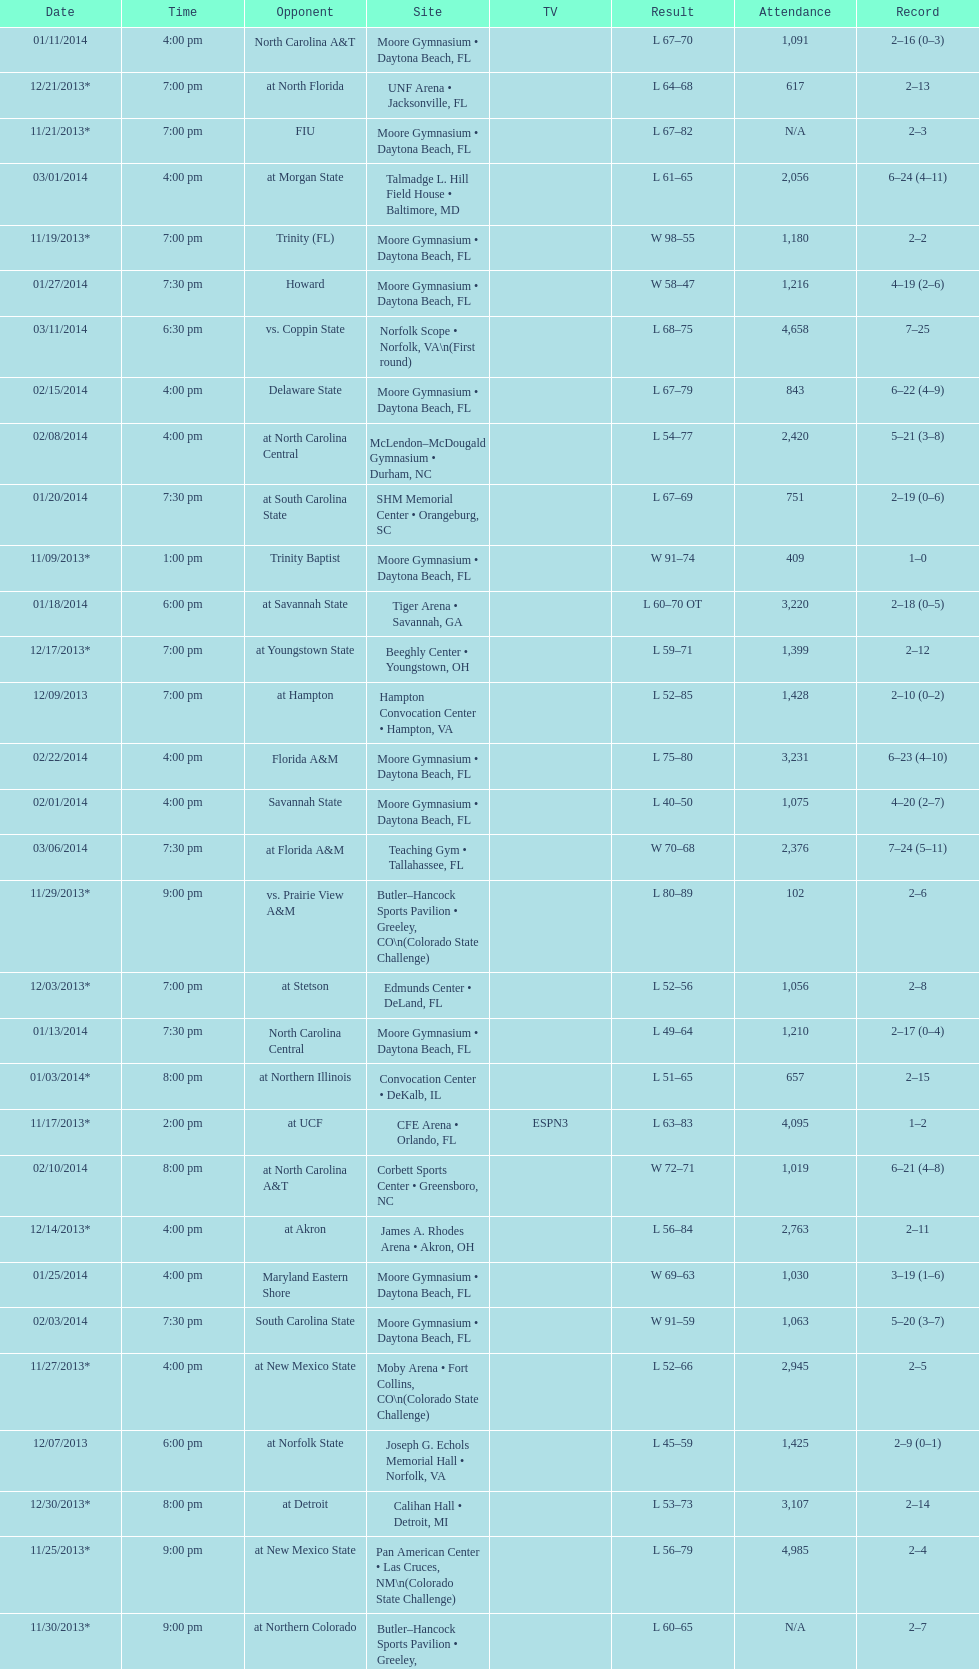What is the total attendance on 11/09/2013? 409. 